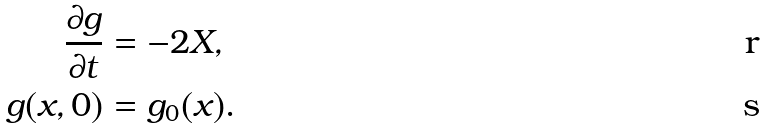Convert formula to latex. <formula><loc_0><loc_0><loc_500><loc_500>\frac { \partial g } { \partial t } & = - 2 X , \\ g ( x , 0 ) & = g _ { 0 } ( x ) .</formula> 